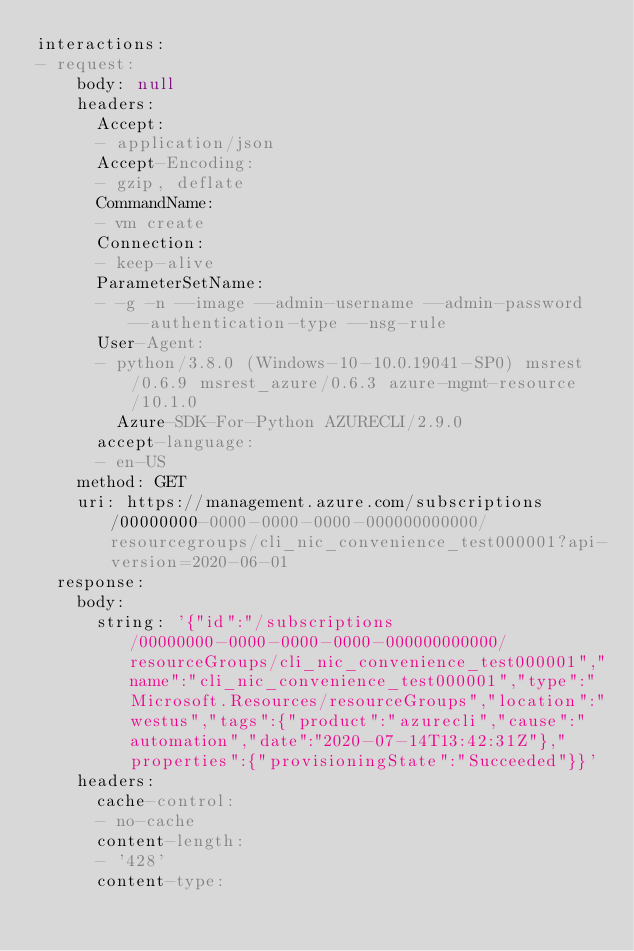Convert code to text. <code><loc_0><loc_0><loc_500><loc_500><_YAML_>interactions:
- request:
    body: null
    headers:
      Accept:
      - application/json
      Accept-Encoding:
      - gzip, deflate
      CommandName:
      - vm create
      Connection:
      - keep-alive
      ParameterSetName:
      - -g -n --image --admin-username --admin-password --authentication-type --nsg-rule
      User-Agent:
      - python/3.8.0 (Windows-10-10.0.19041-SP0) msrest/0.6.9 msrest_azure/0.6.3 azure-mgmt-resource/10.1.0
        Azure-SDK-For-Python AZURECLI/2.9.0
      accept-language:
      - en-US
    method: GET
    uri: https://management.azure.com/subscriptions/00000000-0000-0000-0000-000000000000/resourcegroups/cli_nic_convenience_test000001?api-version=2020-06-01
  response:
    body:
      string: '{"id":"/subscriptions/00000000-0000-0000-0000-000000000000/resourceGroups/cli_nic_convenience_test000001","name":"cli_nic_convenience_test000001","type":"Microsoft.Resources/resourceGroups","location":"westus","tags":{"product":"azurecli","cause":"automation","date":"2020-07-14T13:42:31Z"},"properties":{"provisioningState":"Succeeded"}}'
    headers:
      cache-control:
      - no-cache
      content-length:
      - '428'
      content-type:</code> 